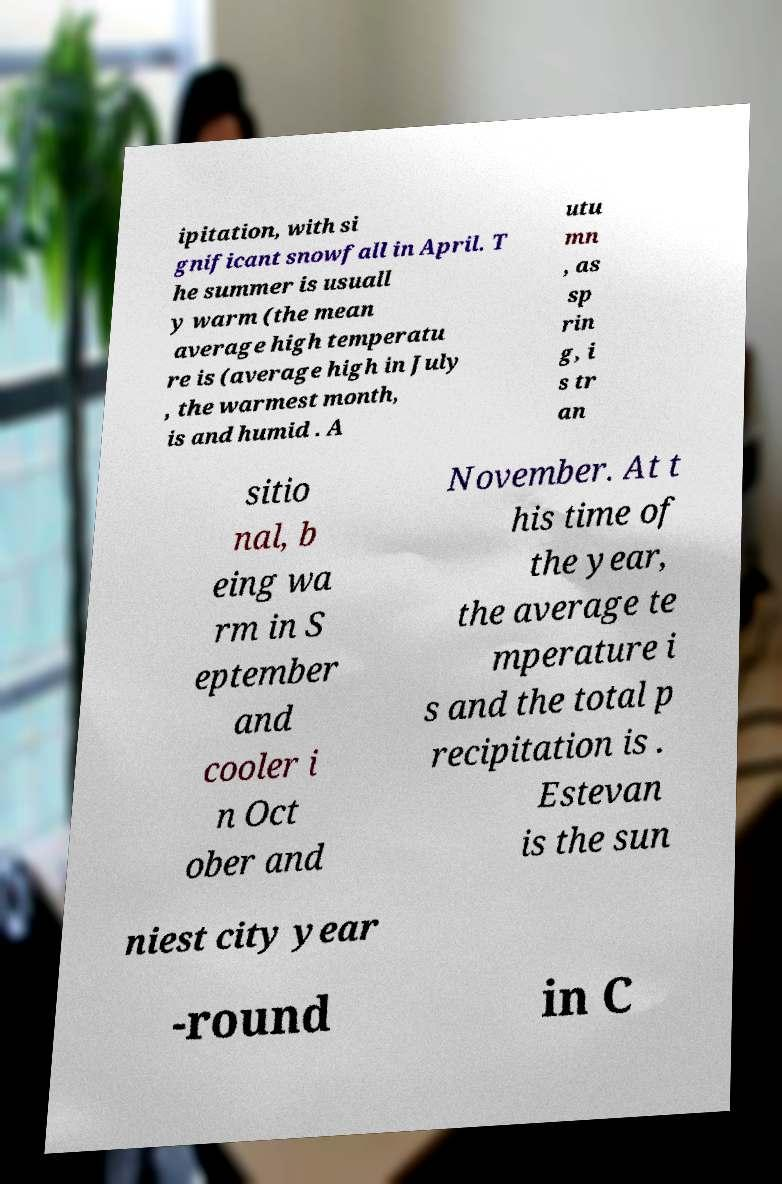There's text embedded in this image that I need extracted. Can you transcribe it verbatim? ipitation, with si gnificant snowfall in April. T he summer is usuall y warm (the mean average high temperatu re is (average high in July , the warmest month, is and humid . A utu mn , as sp rin g, i s tr an sitio nal, b eing wa rm in S eptember and cooler i n Oct ober and November. At t his time of the year, the average te mperature i s and the total p recipitation is . Estevan is the sun niest city year -round in C 